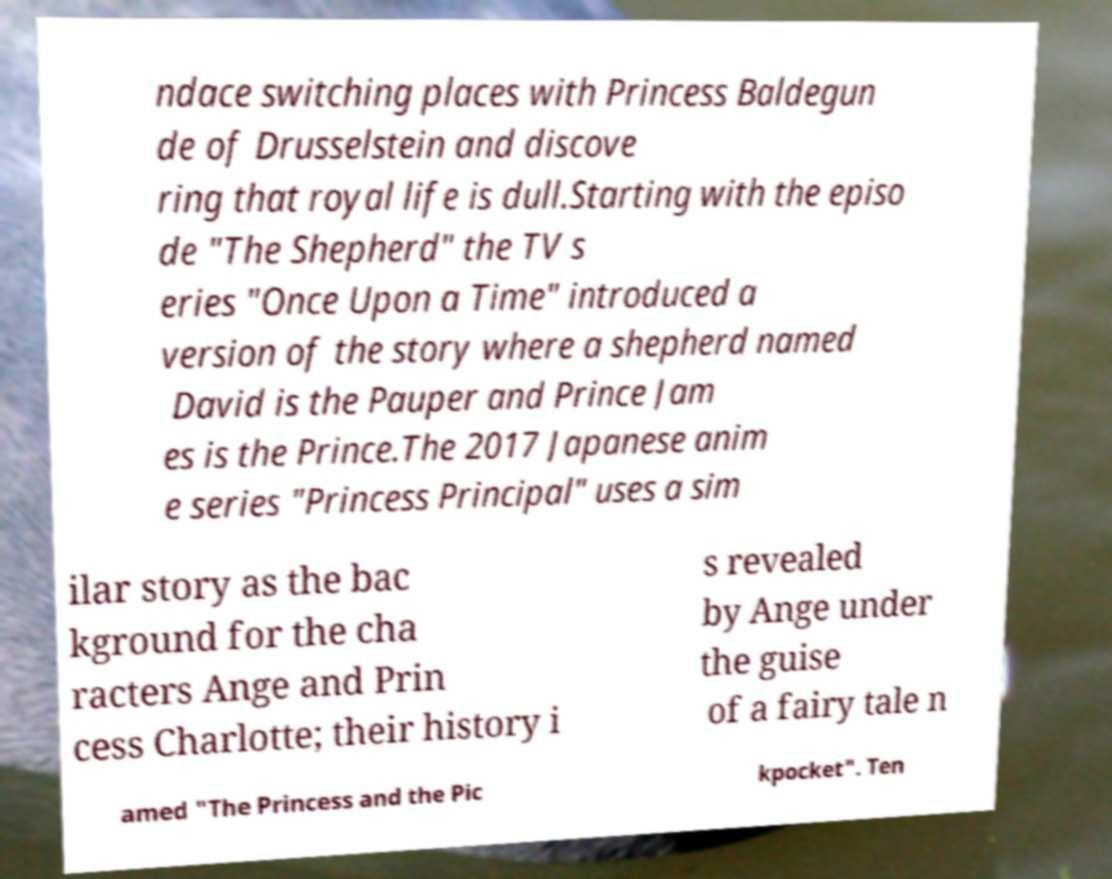Please identify and transcribe the text found in this image. ndace switching places with Princess Baldegun de of Drusselstein and discove ring that royal life is dull.Starting with the episo de "The Shepherd" the TV s eries "Once Upon a Time" introduced a version of the story where a shepherd named David is the Pauper and Prince Jam es is the Prince.The 2017 Japanese anim e series "Princess Principal" uses a sim ilar story as the bac kground for the cha racters Ange and Prin cess Charlotte; their history i s revealed by Ange under the guise of a fairy tale n amed "The Princess and the Pic kpocket". Ten 